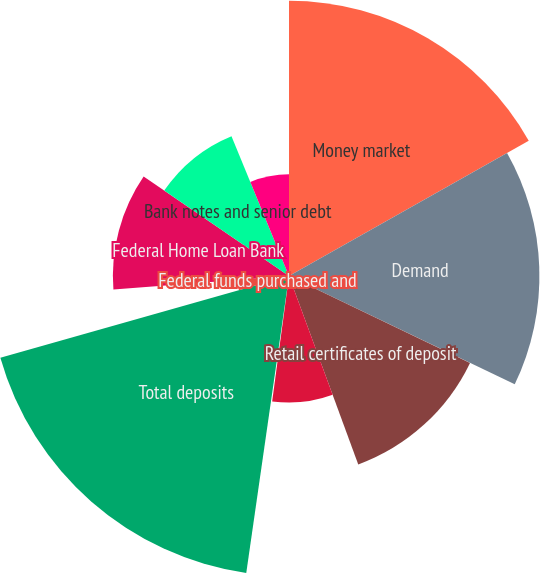Convert chart. <chart><loc_0><loc_0><loc_500><loc_500><pie_chart><fcel>Money market<fcel>Demand<fcel>Retail certificates of deposit<fcel>Savings<fcel>Time deposits in foreign<fcel>Total deposits<fcel>Federal funds purchased and<fcel>Federal Home Loan Bank<fcel>Bank notes and senior debt<fcel>Subordinated debt<nl><fcel>16.82%<fcel>15.3%<fcel>12.27%<fcel>7.73%<fcel>0.15%<fcel>18.33%<fcel>3.18%<fcel>10.76%<fcel>9.24%<fcel>6.21%<nl></chart> 